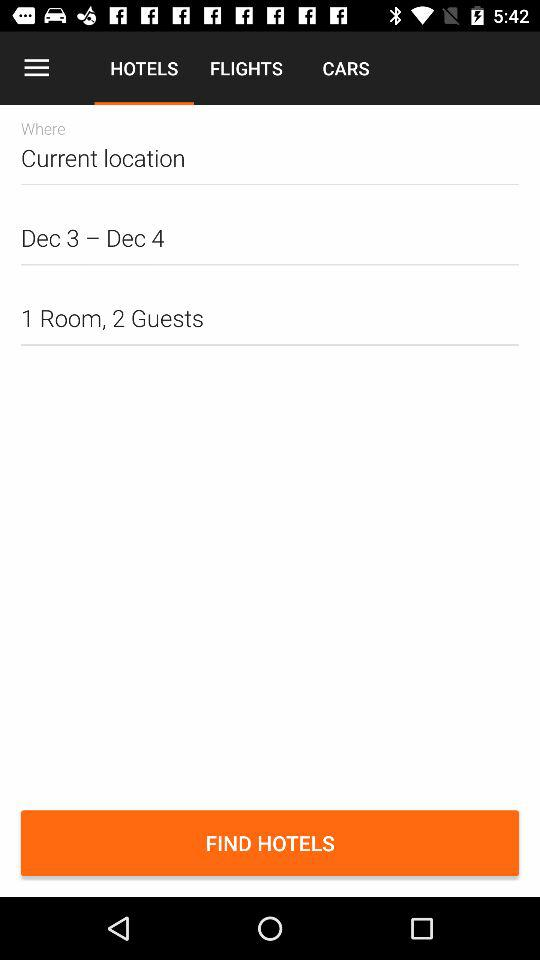What tab is selected? The selected tab is "HOTELS". 